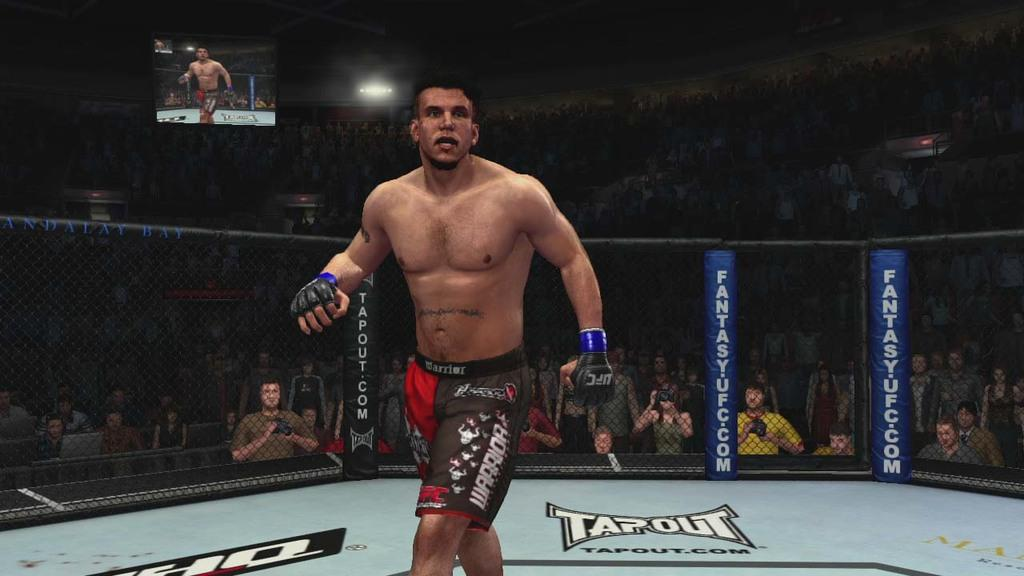<image>
Offer a succinct explanation of the picture presented. An image of a UFC fighter in a video game in a rink with the word Tapout on the ground. 